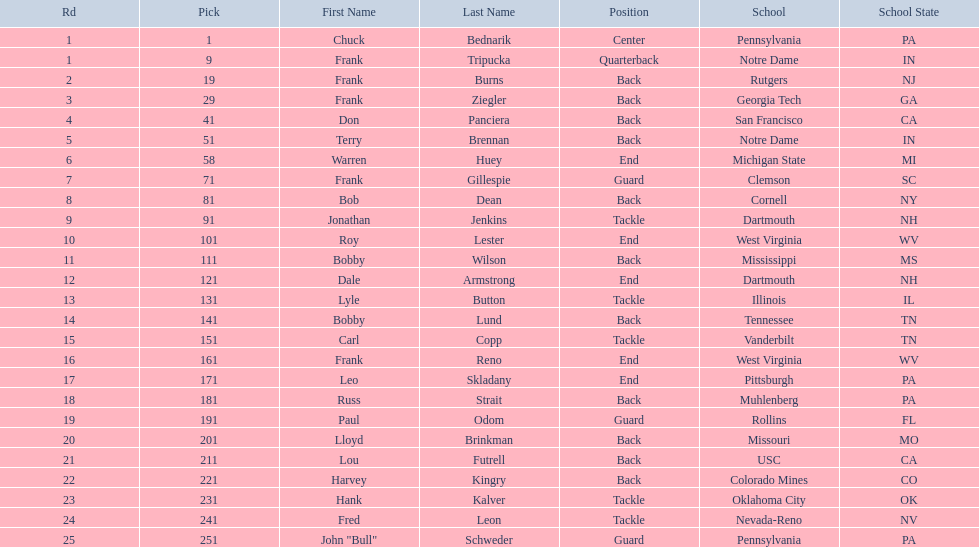Most prevalent school Pennsylvania. 